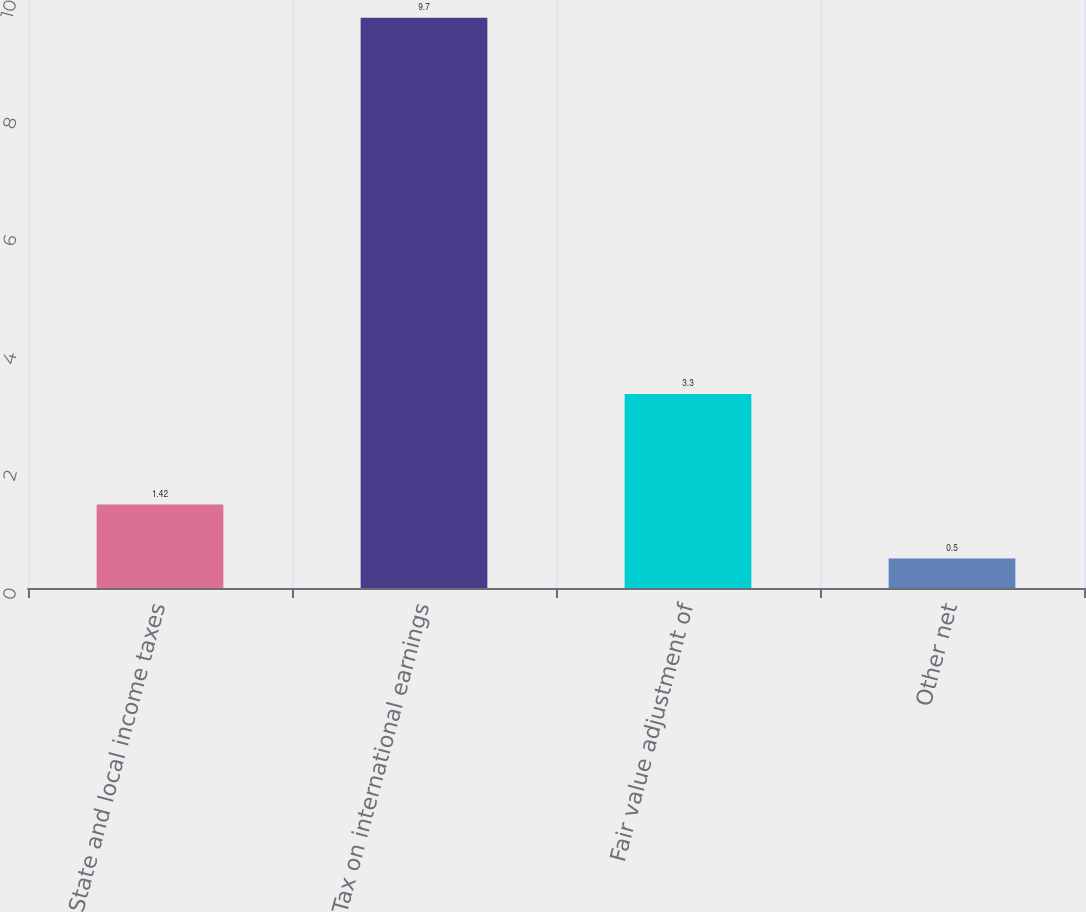Convert chart. <chart><loc_0><loc_0><loc_500><loc_500><bar_chart><fcel>State and local income taxes<fcel>Tax on international earnings<fcel>Fair value adjustment of<fcel>Other net<nl><fcel>1.42<fcel>9.7<fcel>3.3<fcel>0.5<nl></chart> 